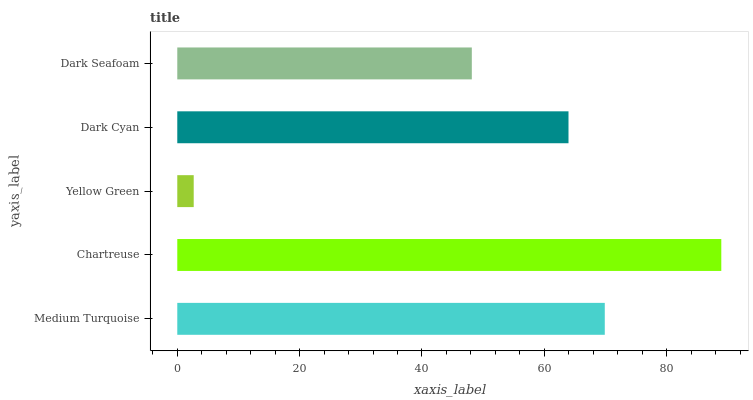Is Yellow Green the minimum?
Answer yes or no. Yes. Is Chartreuse the maximum?
Answer yes or no. Yes. Is Chartreuse the minimum?
Answer yes or no. No. Is Yellow Green the maximum?
Answer yes or no. No. Is Chartreuse greater than Yellow Green?
Answer yes or no. Yes. Is Yellow Green less than Chartreuse?
Answer yes or no. Yes. Is Yellow Green greater than Chartreuse?
Answer yes or no. No. Is Chartreuse less than Yellow Green?
Answer yes or no. No. Is Dark Cyan the high median?
Answer yes or no. Yes. Is Dark Cyan the low median?
Answer yes or no. Yes. Is Medium Turquoise the high median?
Answer yes or no. No. Is Yellow Green the low median?
Answer yes or no. No. 